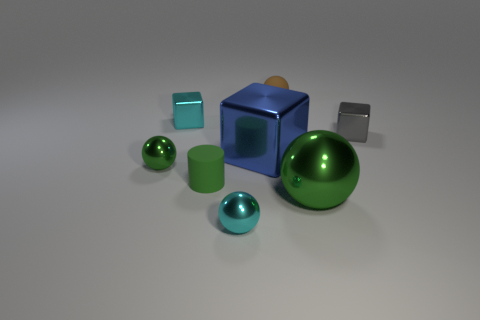Subtract all red blocks. How many green spheres are left? 2 Subtract all gray blocks. How many blocks are left? 2 Add 2 big green shiny spheres. How many objects exist? 10 Subtract all brown spheres. How many spheres are left? 3 Add 3 tiny blue metal spheres. How many tiny blue metal spheres exist? 3 Subtract 1 brown balls. How many objects are left? 7 Subtract all blocks. How many objects are left? 5 Subtract all gray spheres. Subtract all cyan cylinders. How many spheres are left? 4 Subtract all green shiny things. Subtract all big blue objects. How many objects are left? 5 Add 2 big shiny balls. How many big shiny balls are left? 3 